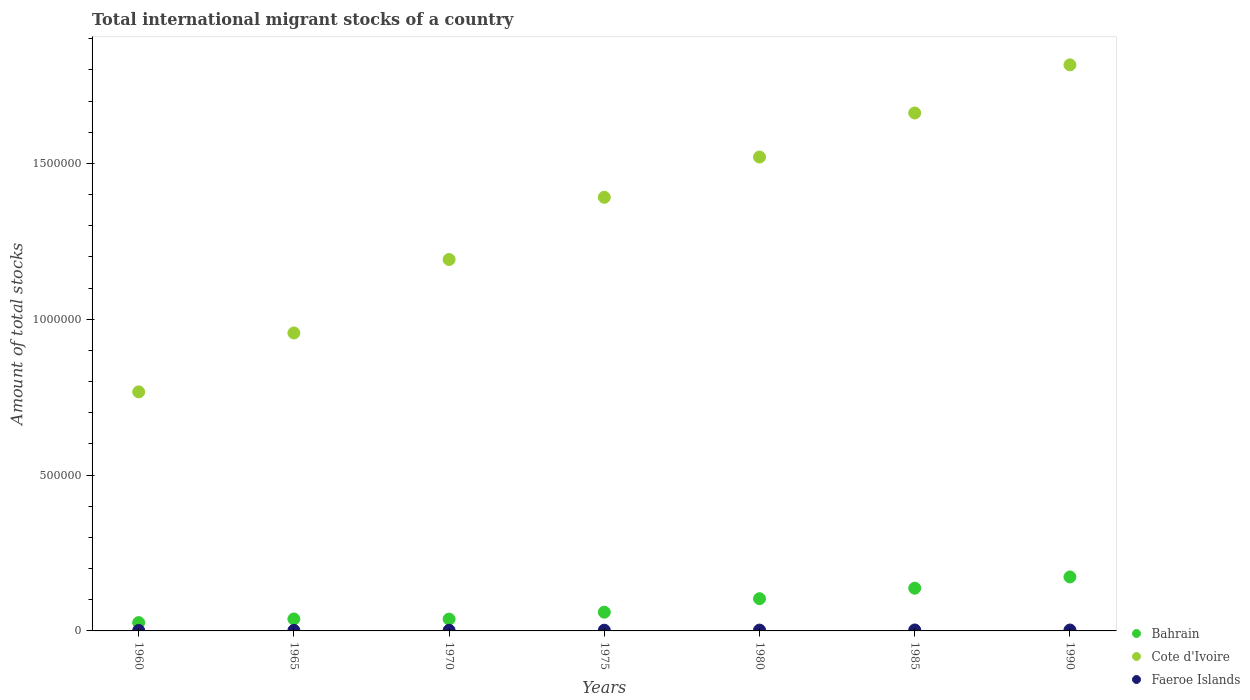Is the number of dotlines equal to the number of legend labels?
Your answer should be very brief. Yes. What is the amount of total stocks in in Bahrain in 1990?
Make the answer very short. 1.73e+05. Across all years, what is the maximum amount of total stocks in in Bahrain?
Provide a short and direct response. 1.73e+05. Across all years, what is the minimum amount of total stocks in in Bahrain?
Provide a short and direct response. 2.67e+04. In which year was the amount of total stocks in in Bahrain maximum?
Provide a short and direct response. 1990. What is the total amount of total stocks in in Faeroe Islands in the graph?
Offer a very short reply. 1.60e+04. What is the difference between the amount of total stocks in in Cote d'Ivoire in 1970 and that in 1980?
Your answer should be compact. -3.29e+05. What is the difference between the amount of total stocks in in Faeroe Islands in 1990 and the amount of total stocks in in Cote d'Ivoire in 1980?
Your answer should be compact. -1.52e+06. What is the average amount of total stocks in in Cote d'Ivoire per year?
Your response must be concise. 1.33e+06. In the year 1990, what is the difference between the amount of total stocks in in Cote d'Ivoire and amount of total stocks in in Bahrain?
Your answer should be compact. 1.64e+06. What is the ratio of the amount of total stocks in in Bahrain in 1960 to that in 1970?
Make the answer very short. 0.7. What is the difference between the highest and the second highest amount of total stocks in in Cote d'Ivoire?
Offer a terse response. 1.54e+05. What is the difference between the highest and the lowest amount of total stocks in in Cote d'Ivoire?
Provide a succinct answer. 1.05e+06. Is the amount of total stocks in in Cote d'Ivoire strictly greater than the amount of total stocks in in Faeroe Islands over the years?
Provide a succinct answer. Yes. Is the amount of total stocks in in Faeroe Islands strictly less than the amount of total stocks in in Bahrain over the years?
Provide a succinct answer. Yes. How many dotlines are there?
Ensure brevity in your answer.  3. Does the graph contain grids?
Provide a short and direct response. No. Where does the legend appear in the graph?
Ensure brevity in your answer.  Bottom right. How many legend labels are there?
Make the answer very short. 3. How are the legend labels stacked?
Your answer should be very brief. Vertical. What is the title of the graph?
Your answer should be very brief. Total international migrant stocks of a country. Does "Low income" appear as one of the legend labels in the graph?
Offer a terse response. No. What is the label or title of the Y-axis?
Your answer should be compact. Amount of total stocks. What is the Amount of total stocks of Bahrain in 1960?
Your response must be concise. 2.67e+04. What is the Amount of total stocks of Cote d'Ivoire in 1960?
Offer a very short reply. 7.67e+05. What is the Amount of total stocks in Faeroe Islands in 1960?
Offer a very short reply. 1489. What is the Amount of total stocks of Bahrain in 1965?
Provide a short and direct response. 3.84e+04. What is the Amount of total stocks of Cote d'Ivoire in 1965?
Offer a terse response. 9.56e+05. What is the Amount of total stocks of Faeroe Islands in 1965?
Offer a terse response. 1716. What is the Amount of total stocks of Bahrain in 1970?
Offer a very short reply. 3.79e+04. What is the Amount of total stocks in Cote d'Ivoire in 1970?
Your answer should be compact. 1.19e+06. What is the Amount of total stocks in Faeroe Islands in 1970?
Your response must be concise. 1978. What is the Amount of total stocks in Bahrain in 1975?
Offer a terse response. 6.01e+04. What is the Amount of total stocks in Cote d'Ivoire in 1975?
Your answer should be very brief. 1.39e+06. What is the Amount of total stocks of Faeroe Islands in 1975?
Offer a terse response. 2280. What is the Amount of total stocks in Bahrain in 1980?
Ensure brevity in your answer.  1.03e+05. What is the Amount of total stocks in Cote d'Ivoire in 1980?
Your answer should be very brief. 1.52e+06. What is the Amount of total stocks in Faeroe Islands in 1980?
Ensure brevity in your answer.  2628. What is the Amount of total stocks of Bahrain in 1985?
Keep it short and to the point. 1.37e+05. What is the Amount of total stocks of Cote d'Ivoire in 1985?
Your response must be concise. 1.66e+06. What is the Amount of total stocks in Faeroe Islands in 1985?
Offer a very short reply. 3029. What is the Amount of total stocks of Bahrain in 1990?
Offer a very short reply. 1.73e+05. What is the Amount of total stocks of Cote d'Ivoire in 1990?
Your answer should be compact. 1.82e+06. What is the Amount of total stocks of Faeroe Islands in 1990?
Offer a terse response. 2881. Across all years, what is the maximum Amount of total stocks in Bahrain?
Provide a succinct answer. 1.73e+05. Across all years, what is the maximum Amount of total stocks of Cote d'Ivoire?
Provide a succinct answer. 1.82e+06. Across all years, what is the maximum Amount of total stocks of Faeroe Islands?
Offer a very short reply. 3029. Across all years, what is the minimum Amount of total stocks in Bahrain?
Your answer should be compact. 2.67e+04. Across all years, what is the minimum Amount of total stocks in Cote d'Ivoire?
Provide a succinct answer. 7.67e+05. Across all years, what is the minimum Amount of total stocks of Faeroe Islands?
Your answer should be very brief. 1489. What is the total Amount of total stocks in Bahrain in the graph?
Provide a short and direct response. 5.77e+05. What is the total Amount of total stocks of Cote d'Ivoire in the graph?
Keep it short and to the point. 9.31e+06. What is the total Amount of total stocks in Faeroe Islands in the graph?
Ensure brevity in your answer.  1.60e+04. What is the difference between the Amount of total stocks in Bahrain in 1960 and that in 1965?
Make the answer very short. -1.16e+04. What is the difference between the Amount of total stocks of Cote d'Ivoire in 1960 and that in 1965?
Your answer should be compact. -1.89e+05. What is the difference between the Amount of total stocks of Faeroe Islands in 1960 and that in 1965?
Ensure brevity in your answer.  -227. What is the difference between the Amount of total stocks in Bahrain in 1960 and that in 1970?
Provide a succinct answer. -1.12e+04. What is the difference between the Amount of total stocks in Cote d'Ivoire in 1960 and that in 1970?
Your response must be concise. -4.25e+05. What is the difference between the Amount of total stocks of Faeroe Islands in 1960 and that in 1970?
Give a very brief answer. -489. What is the difference between the Amount of total stocks in Bahrain in 1960 and that in 1975?
Give a very brief answer. -3.34e+04. What is the difference between the Amount of total stocks of Cote d'Ivoire in 1960 and that in 1975?
Offer a terse response. -6.24e+05. What is the difference between the Amount of total stocks of Faeroe Islands in 1960 and that in 1975?
Your answer should be compact. -791. What is the difference between the Amount of total stocks of Bahrain in 1960 and that in 1980?
Provide a short and direct response. -7.67e+04. What is the difference between the Amount of total stocks in Cote d'Ivoire in 1960 and that in 1980?
Offer a very short reply. -7.54e+05. What is the difference between the Amount of total stocks of Faeroe Islands in 1960 and that in 1980?
Ensure brevity in your answer.  -1139. What is the difference between the Amount of total stocks in Bahrain in 1960 and that in 1985?
Offer a very short reply. -1.10e+05. What is the difference between the Amount of total stocks in Cote d'Ivoire in 1960 and that in 1985?
Keep it short and to the point. -8.95e+05. What is the difference between the Amount of total stocks in Faeroe Islands in 1960 and that in 1985?
Provide a short and direct response. -1540. What is the difference between the Amount of total stocks in Bahrain in 1960 and that in 1990?
Provide a short and direct response. -1.46e+05. What is the difference between the Amount of total stocks in Cote d'Ivoire in 1960 and that in 1990?
Provide a short and direct response. -1.05e+06. What is the difference between the Amount of total stocks in Faeroe Islands in 1960 and that in 1990?
Give a very brief answer. -1392. What is the difference between the Amount of total stocks of Bahrain in 1965 and that in 1970?
Provide a succinct answer. 411. What is the difference between the Amount of total stocks in Cote d'Ivoire in 1965 and that in 1970?
Your response must be concise. -2.36e+05. What is the difference between the Amount of total stocks of Faeroe Islands in 1965 and that in 1970?
Your answer should be compact. -262. What is the difference between the Amount of total stocks of Bahrain in 1965 and that in 1975?
Offer a very short reply. -2.17e+04. What is the difference between the Amount of total stocks of Cote d'Ivoire in 1965 and that in 1975?
Your answer should be very brief. -4.35e+05. What is the difference between the Amount of total stocks of Faeroe Islands in 1965 and that in 1975?
Ensure brevity in your answer.  -564. What is the difference between the Amount of total stocks in Bahrain in 1965 and that in 1980?
Provide a short and direct response. -6.51e+04. What is the difference between the Amount of total stocks of Cote d'Ivoire in 1965 and that in 1980?
Give a very brief answer. -5.65e+05. What is the difference between the Amount of total stocks of Faeroe Islands in 1965 and that in 1980?
Provide a succinct answer. -912. What is the difference between the Amount of total stocks of Bahrain in 1965 and that in 1985?
Your answer should be very brief. -9.87e+04. What is the difference between the Amount of total stocks of Cote d'Ivoire in 1965 and that in 1985?
Provide a succinct answer. -7.06e+05. What is the difference between the Amount of total stocks of Faeroe Islands in 1965 and that in 1985?
Offer a very short reply. -1313. What is the difference between the Amount of total stocks of Bahrain in 1965 and that in 1990?
Your answer should be very brief. -1.35e+05. What is the difference between the Amount of total stocks of Cote d'Ivoire in 1965 and that in 1990?
Your answer should be compact. -8.60e+05. What is the difference between the Amount of total stocks of Faeroe Islands in 1965 and that in 1990?
Your response must be concise. -1165. What is the difference between the Amount of total stocks of Bahrain in 1970 and that in 1975?
Offer a very short reply. -2.21e+04. What is the difference between the Amount of total stocks of Cote d'Ivoire in 1970 and that in 1975?
Offer a very short reply. -2.00e+05. What is the difference between the Amount of total stocks in Faeroe Islands in 1970 and that in 1975?
Provide a succinct answer. -302. What is the difference between the Amount of total stocks of Bahrain in 1970 and that in 1980?
Give a very brief answer. -6.55e+04. What is the difference between the Amount of total stocks in Cote d'Ivoire in 1970 and that in 1980?
Make the answer very short. -3.29e+05. What is the difference between the Amount of total stocks of Faeroe Islands in 1970 and that in 1980?
Make the answer very short. -650. What is the difference between the Amount of total stocks in Bahrain in 1970 and that in 1985?
Keep it short and to the point. -9.91e+04. What is the difference between the Amount of total stocks of Cote d'Ivoire in 1970 and that in 1985?
Give a very brief answer. -4.70e+05. What is the difference between the Amount of total stocks in Faeroe Islands in 1970 and that in 1985?
Your answer should be compact. -1051. What is the difference between the Amount of total stocks of Bahrain in 1970 and that in 1990?
Make the answer very short. -1.35e+05. What is the difference between the Amount of total stocks in Cote d'Ivoire in 1970 and that in 1990?
Ensure brevity in your answer.  -6.25e+05. What is the difference between the Amount of total stocks in Faeroe Islands in 1970 and that in 1990?
Ensure brevity in your answer.  -903. What is the difference between the Amount of total stocks of Bahrain in 1975 and that in 1980?
Your response must be concise. -4.34e+04. What is the difference between the Amount of total stocks of Cote d'Ivoire in 1975 and that in 1980?
Your answer should be compact. -1.29e+05. What is the difference between the Amount of total stocks of Faeroe Islands in 1975 and that in 1980?
Offer a very short reply. -348. What is the difference between the Amount of total stocks of Bahrain in 1975 and that in 1985?
Your response must be concise. -7.70e+04. What is the difference between the Amount of total stocks in Cote d'Ivoire in 1975 and that in 1985?
Provide a succinct answer. -2.71e+05. What is the difference between the Amount of total stocks of Faeroe Islands in 1975 and that in 1985?
Your response must be concise. -749. What is the difference between the Amount of total stocks of Bahrain in 1975 and that in 1990?
Your response must be concise. -1.13e+05. What is the difference between the Amount of total stocks in Cote d'Ivoire in 1975 and that in 1990?
Keep it short and to the point. -4.25e+05. What is the difference between the Amount of total stocks in Faeroe Islands in 1975 and that in 1990?
Your response must be concise. -601. What is the difference between the Amount of total stocks of Bahrain in 1980 and that in 1985?
Your answer should be compact. -3.36e+04. What is the difference between the Amount of total stocks in Cote d'Ivoire in 1980 and that in 1985?
Offer a terse response. -1.41e+05. What is the difference between the Amount of total stocks of Faeroe Islands in 1980 and that in 1985?
Provide a succinct answer. -401. What is the difference between the Amount of total stocks in Bahrain in 1980 and that in 1990?
Provide a short and direct response. -6.97e+04. What is the difference between the Amount of total stocks in Cote d'Ivoire in 1980 and that in 1990?
Provide a succinct answer. -2.96e+05. What is the difference between the Amount of total stocks in Faeroe Islands in 1980 and that in 1990?
Provide a short and direct response. -253. What is the difference between the Amount of total stocks in Bahrain in 1985 and that in 1990?
Provide a succinct answer. -3.61e+04. What is the difference between the Amount of total stocks in Cote d'Ivoire in 1985 and that in 1990?
Provide a short and direct response. -1.54e+05. What is the difference between the Amount of total stocks of Faeroe Islands in 1985 and that in 1990?
Provide a succinct answer. 148. What is the difference between the Amount of total stocks in Bahrain in 1960 and the Amount of total stocks in Cote d'Ivoire in 1965?
Offer a very short reply. -9.29e+05. What is the difference between the Amount of total stocks of Bahrain in 1960 and the Amount of total stocks of Faeroe Islands in 1965?
Offer a terse response. 2.50e+04. What is the difference between the Amount of total stocks of Cote d'Ivoire in 1960 and the Amount of total stocks of Faeroe Islands in 1965?
Give a very brief answer. 7.65e+05. What is the difference between the Amount of total stocks of Bahrain in 1960 and the Amount of total stocks of Cote d'Ivoire in 1970?
Ensure brevity in your answer.  -1.17e+06. What is the difference between the Amount of total stocks in Bahrain in 1960 and the Amount of total stocks in Faeroe Islands in 1970?
Your answer should be compact. 2.48e+04. What is the difference between the Amount of total stocks of Cote d'Ivoire in 1960 and the Amount of total stocks of Faeroe Islands in 1970?
Offer a very short reply. 7.65e+05. What is the difference between the Amount of total stocks in Bahrain in 1960 and the Amount of total stocks in Cote d'Ivoire in 1975?
Keep it short and to the point. -1.36e+06. What is the difference between the Amount of total stocks of Bahrain in 1960 and the Amount of total stocks of Faeroe Islands in 1975?
Provide a short and direct response. 2.45e+04. What is the difference between the Amount of total stocks of Cote d'Ivoire in 1960 and the Amount of total stocks of Faeroe Islands in 1975?
Keep it short and to the point. 7.65e+05. What is the difference between the Amount of total stocks of Bahrain in 1960 and the Amount of total stocks of Cote d'Ivoire in 1980?
Ensure brevity in your answer.  -1.49e+06. What is the difference between the Amount of total stocks of Bahrain in 1960 and the Amount of total stocks of Faeroe Islands in 1980?
Ensure brevity in your answer.  2.41e+04. What is the difference between the Amount of total stocks of Cote d'Ivoire in 1960 and the Amount of total stocks of Faeroe Islands in 1980?
Give a very brief answer. 7.64e+05. What is the difference between the Amount of total stocks in Bahrain in 1960 and the Amount of total stocks in Cote d'Ivoire in 1985?
Give a very brief answer. -1.64e+06. What is the difference between the Amount of total stocks in Bahrain in 1960 and the Amount of total stocks in Faeroe Islands in 1985?
Provide a short and direct response. 2.37e+04. What is the difference between the Amount of total stocks in Cote d'Ivoire in 1960 and the Amount of total stocks in Faeroe Islands in 1985?
Give a very brief answer. 7.64e+05. What is the difference between the Amount of total stocks in Bahrain in 1960 and the Amount of total stocks in Cote d'Ivoire in 1990?
Provide a succinct answer. -1.79e+06. What is the difference between the Amount of total stocks in Bahrain in 1960 and the Amount of total stocks in Faeroe Islands in 1990?
Your response must be concise. 2.39e+04. What is the difference between the Amount of total stocks of Cote d'Ivoire in 1960 and the Amount of total stocks of Faeroe Islands in 1990?
Your response must be concise. 7.64e+05. What is the difference between the Amount of total stocks in Bahrain in 1965 and the Amount of total stocks in Cote d'Ivoire in 1970?
Make the answer very short. -1.15e+06. What is the difference between the Amount of total stocks in Bahrain in 1965 and the Amount of total stocks in Faeroe Islands in 1970?
Your answer should be very brief. 3.64e+04. What is the difference between the Amount of total stocks in Cote d'Ivoire in 1965 and the Amount of total stocks in Faeroe Islands in 1970?
Your response must be concise. 9.54e+05. What is the difference between the Amount of total stocks in Bahrain in 1965 and the Amount of total stocks in Cote d'Ivoire in 1975?
Offer a very short reply. -1.35e+06. What is the difference between the Amount of total stocks of Bahrain in 1965 and the Amount of total stocks of Faeroe Islands in 1975?
Provide a succinct answer. 3.61e+04. What is the difference between the Amount of total stocks in Cote d'Ivoire in 1965 and the Amount of total stocks in Faeroe Islands in 1975?
Your response must be concise. 9.54e+05. What is the difference between the Amount of total stocks of Bahrain in 1965 and the Amount of total stocks of Cote d'Ivoire in 1980?
Offer a terse response. -1.48e+06. What is the difference between the Amount of total stocks in Bahrain in 1965 and the Amount of total stocks in Faeroe Islands in 1980?
Your response must be concise. 3.57e+04. What is the difference between the Amount of total stocks of Cote d'Ivoire in 1965 and the Amount of total stocks of Faeroe Islands in 1980?
Offer a terse response. 9.53e+05. What is the difference between the Amount of total stocks of Bahrain in 1965 and the Amount of total stocks of Cote d'Ivoire in 1985?
Make the answer very short. -1.62e+06. What is the difference between the Amount of total stocks in Bahrain in 1965 and the Amount of total stocks in Faeroe Islands in 1985?
Provide a short and direct response. 3.53e+04. What is the difference between the Amount of total stocks in Cote d'Ivoire in 1965 and the Amount of total stocks in Faeroe Islands in 1985?
Provide a short and direct response. 9.53e+05. What is the difference between the Amount of total stocks of Bahrain in 1965 and the Amount of total stocks of Cote d'Ivoire in 1990?
Give a very brief answer. -1.78e+06. What is the difference between the Amount of total stocks of Bahrain in 1965 and the Amount of total stocks of Faeroe Islands in 1990?
Your answer should be very brief. 3.55e+04. What is the difference between the Amount of total stocks of Cote d'Ivoire in 1965 and the Amount of total stocks of Faeroe Islands in 1990?
Make the answer very short. 9.53e+05. What is the difference between the Amount of total stocks of Bahrain in 1970 and the Amount of total stocks of Cote d'Ivoire in 1975?
Make the answer very short. -1.35e+06. What is the difference between the Amount of total stocks in Bahrain in 1970 and the Amount of total stocks in Faeroe Islands in 1975?
Your answer should be compact. 3.57e+04. What is the difference between the Amount of total stocks in Cote d'Ivoire in 1970 and the Amount of total stocks in Faeroe Islands in 1975?
Provide a short and direct response. 1.19e+06. What is the difference between the Amount of total stocks of Bahrain in 1970 and the Amount of total stocks of Cote d'Ivoire in 1980?
Your response must be concise. -1.48e+06. What is the difference between the Amount of total stocks in Bahrain in 1970 and the Amount of total stocks in Faeroe Islands in 1980?
Give a very brief answer. 3.53e+04. What is the difference between the Amount of total stocks of Cote d'Ivoire in 1970 and the Amount of total stocks of Faeroe Islands in 1980?
Your answer should be very brief. 1.19e+06. What is the difference between the Amount of total stocks of Bahrain in 1970 and the Amount of total stocks of Cote d'Ivoire in 1985?
Your response must be concise. -1.62e+06. What is the difference between the Amount of total stocks of Bahrain in 1970 and the Amount of total stocks of Faeroe Islands in 1985?
Give a very brief answer. 3.49e+04. What is the difference between the Amount of total stocks of Cote d'Ivoire in 1970 and the Amount of total stocks of Faeroe Islands in 1985?
Provide a short and direct response. 1.19e+06. What is the difference between the Amount of total stocks in Bahrain in 1970 and the Amount of total stocks in Cote d'Ivoire in 1990?
Ensure brevity in your answer.  -1.78e+06. What is the difference between the Amount of total stocks in Bahrain in 1970 and the Amount of total stocks in Faeroe Islands in 1990?
Ensure brevity in your answer.  3.51e+04. What is the difference between the Amount of total stocks of Cote d'Ivoire in 1970 and the Amount of total stocks of Faeroe Islands in 1990?
Your answer should be compact. 1.19e+06. What is the difference between the Amount of total stocks of Bahrain in 1975 and the Amount of total stocks of Cote d'Ivoire in 1980?
Give a very brief answer. -1.46e+06. What is the difference between the Amount of total stocks of Bahrain in 1975 and the Amount of total stocks of Faeroe Islands in 1980?
Make the answer very short. 5.75e+04. What is the difference between the Amount of total stocks of Cote d'Ivoire in 1975 and the Amount of total stocks of Faeroe Islands in 1980?
Offer a terse response. 1.39e+06. What is the difference between the Amount of total stocks of Bahrain in 1975 and the Amount of total stocks of Cote d'Ivoire in 1985?
Ensure brevity in your answer.  -1.60e+06. What is the difference between the Amount of total stocks of Bahrain in 1975 and the Amount of total stocks of Faeroe Islands in 1985?
Your response must be concise. 5.71e+04. What is the difference between the Amount of total stocks in Cote d'Ivoire in 1975 and the Amount of total stocks in Faeroe Islands in 1985?
Your response must be concise. 1.39e+06. What is the difference between the Amount of total stocks in Bahrain in 1975 and the Amount of total stocks in Cote d'Ivoire in 1990?
Your answer should be compact. -1.76e+06. What is the difference between the Amount of total stocks in Bahrain in 1975 and the Amount of total stocks in Faeroe Islands in 1990?
Keep it short and to the point. 5.72e+04. What is the difference between the Amount of total stocks of Cote d'Ivoire in 1975 and the Amount of total stocks of Faeroe Islands in 1990?
Ensure brevity in your answer.  1.39e+06. What is the difference between the Amount of total stocks of Bahrain in 1980 and the Amount of total stocks of Cote d'Ivoire in 1985?
Provide a succinct answer. -1.56e+06. What is the difference between the Amount of total stocks in Bahrain in 1980 and the Amount of total stocks in Faeroe Islands in 1985?
Give a very brief answer. 1.00e+05. What is the difference between the Amount of total stocks in Cote d'Ivoire in 1980 and the Amount of total stocks in Faeroe Islands in 1985?
Give a very brief answer. 1.52e+06. What is the difference between the Amount of total stocks in Bahrain in 1980 and the Amount of total stocks in Cote d'Ivoire in 1990?
Your answer should be very brief. -1.71e+06. What is the difference between the Amount of total stocks of Bahrain in 1980 and the Amount of total stocks of Faeroe Islands in 1990?
Keep it short and to the point. 1.01e+05. What is the difference between the Amount of total stocks of Cote d'Ivoire in 1980 and the Amount of total stocks of Faeroe Islands in 1990?
Keep it short and to the point. 1.52e+06. What is the difference between the Amount of total stocks in Bahrain in 1985 and the Amount of total stocks in Cote d'Ivoire in 1990?
Your response must be concise. -1.68e+06. What is the difference between the Amount of total stocks of Bahrain in 1985 and the Amount of total stocks of Faeroe Islands in 1990?
Your answer should be very brief. 1.34e+05. What is the difference between the Amount of total stocks in Cote d'Ivoire in 1985 and the Amount of total stocks in Faeroe Islands in 1990?
Make the answer very short. 1.66e+06. What is the average Amount of total stocks in Bahrain per year?
Your answer should be very brief. 8.24e+04. What is the average Amount of total stocks in Cote d'Ivoire per year?
Make the answer very short. 1.33e+06. What is the average Amount of total stocks of Faeroe Islands per year?
Ensure brevity in your answer.  2285.86. In the year 1960, what is the difference between the Amount of total stocks of Bahrain and Amount of total stocks of Cote d'Ivoire?
Your response must be concise. -7.40e+05. In the year 1960, what is the difference between the Amount of total stocks of Bahrain and Amount of total stocks of Faeroe Islands?
Offer a very short reply. 2.52e+04. In the year 1960, what is the difference between the Amount of total stocks of Cote d'Ivoire and Amount of total stocks of Faeroe Islands?
Give a very brief answer. 7.66e+05. In the year 1965, what is the difference between the Amount of total stocks in Bahrain and Amount of total stocks in Cote d'Ivoire?
Your response must be concise. -9.18e+05. In the year 1965, what is the difference between the Amount of total stocks of Bahrain and Amount of total stocks of Faeroe Islands?
Keep it short and to the point. 3.66e+04. In the year 1965, what is the difference between the Amount of total stocks in Cote d'Ivoire and Amount of total stocks in Faeroe Islands?
Provide a short and direct response. 9.54e+05. In the year 1970, what is the difference between the Amount of total stocks in Bahrain and Amount of total stocks in Cote d'Ivoire?
Your response must be concise. -1.15e+06. In the year 1970, what is the difference between the Amount of total stocks of Bahrain and Amount of total stocks of Faeroe Islands?
Your answer should be compact. 3.60e+04. In the year 1970, what is the difference between the Amount of total stocks in Cote d'Ivoire and Amount of total stocks in Faeroe Islands?
Ensure brevity in your answer.  1.19e+06. In the year 1975, what is the difference between the Amount of total stocks in Bahrain and Amount of total stocks in Cote d'Ivoire?
Ensure brevity in your answer.  -1.33e+06. In the year 1975, what is the difference between the Amount of total stocks in Bahrain and Amount of total stocks in Faeroe Islands?
Keep it short and to the point. 5.78e+04. In the year 1975, what is the difference between the Amount of total stocks in Cote d'Ivoire and Amount of total stocks in Faeroe Islands?
Keep it short and to the point. 1.39e+06. In the year 1980, what is the difference between the Amount of total stocks in Bahrain and Amount of total stocks in Cote d'Ivoire?
Make the answer very short. -1.42e+06. In the year 1980, what is the difference between the Amount of total stocks of Bahrain and Amount of total stocks of Faeroe Islands?
Give a very brief answer. 1.01e+05. In the year 1980, what is the difference between the Amount of total stocks in Cote d'Ivoire and Amount of total stocks in Faeroe Islands?
Your answer should be very brief. 1.52e+06. In the year 1985, what is the difference between the Amount of total stocks of Bahrain and Amount of total stocks of Cote d'Ivoire?
Offer a very short reply. -1.52e+06. In the year 1985, what is the difference between the Amount of total stocks in Bahrain and Amount of total stocks in Faeroe Islands?
Offer a very short reply. 1.34e+05. In the year 1985, what is the difference between the Amount of total stocks in Cote d'Ivoire and Amount of total stocks in Faeroe Islands?
Give a very brief answer. 1.66e+06. In the year 1990, what is the difference between the Amount of total stocks in Bahrain and Amount of total stocks in Cote d'Ivoire?
Keep it short and to the point. -1.64e+06. In the year 1990, what is the difference between the Amount of total stocks in Bahrain and Amount of total stocks in Faeroe Islands?
Your response must be concise. 1.70e+05. In the year 1990, what is the difference between the Amount of total stocks in Cote d'Ivoire and Amount of total stocks in Faeroe Islands?
Make the answer very short. 1.81e+06. What is the ratio of the Amount of total stocks in Bahrain in 1960 to that in 1965?
Offer a terse response. 0.7. What is the ratio of the Amount of total stocks of Cote d'Ivoire in 1960 to that in 1965?
Provide a short and direct response. 0.8. What is the ratio of the Amount of total stocks in Faeroe Islands in 1960 to that in 1965?
Offer a terse response. 0.87. What is the ratio of the Amount of total stocks in Bahrain in 1960 to that in 1970?
Offer a very short reply. 0.7. What is the ratio of the Amount of total stocks of Cote d'Ivoire in 1960 to that in 1970?
Ensure brevity in your answer.  0.64. What is the ratio of the Amount of total stocks of Faeroe Islands in 1960 to that in 1970?
Provide a short and direct response. 0.75. What is the ratio of the Amount of total stocks in Bahrain in 1960 to that in 1975?
Offer a very short reply. 0.44. What is the ratio of the Amount of total stocks in Cote d'Ivoire in 1960 to that in 1975?
Provide a succinct answer. 0.55. What is the ratio of the Amount of total stocks in Faeroe Islands in 1960 to that in 1975?
Make the answer very short. 0.65. What is the ratio of the Amount of total stocks in Bahrain in 1960 to that in 1980?
Provide a succinct answer. 0.26. What is the ratio of the Amount of total stocks of Cote d'Ivoire in 1960 to that in 1980?
Ensure brevity in your answer.  0.5. What is the ratio of the Amount of total stocks in Faeroe Islands in 1960 to that in 1980?
Make the answer very short. 0.57. What is the ratio of the Amount of total stocks in Bahrain in 1960 to that in 1985?
Ensure brevity in your answer.  0.2. What is the ratio of the Amount of total stocks in Cote d'Ivoire in 1960 to that in 1985?
Make the answer very short. 0.46. What is the ratio of the Amount of total stocks in Faeroe Islands in 1960 to that in 1985?
Offer a terse response. 0.49. What is the ratio of the Amount of total stocks of Bahrain in 1960 to that in 1990?
Your answer should be compact. 0.15. What is the ratio of the Amount of total stocks of Cote d'Ivoire in 1960 to that in 1990?
Offer a very short reply. 0.42. What is the ratio of the Amount of total stocks of Faeroe Islands in 1960 to that in 1990?
Your answer should be compact. 0.52. What is the ratio of the Amount of total stocks of Bahrain in 1965 to that in 1970?
Offer a terse response. 1.01. What is the ratio of the Amount of total stocks in Cote d'Ivoire in 1965 to that in 1970?
Your answer should be very brief. 0.8. What is the ratio of the Amount of total stocks in Faeroe Islands in 1965 to that in 1970?
Give a very brief answer. 0.87. What is the ratio of the Amount of total stocks in Bahrain in 1965 to that in 1975?
Give a very brief answer. 0.64. What is the ratio of the Amount of total stocks of Cote d'Ivoire in 1965 to that in 1975?
Make the answer very short. 0.69. What is the ratio of the Amount of total stocks of Faeroe Islands in 1965 to that in 1975?
Make the answer very short. 0.75. What is the ratio of the Amount of total stocks of Bahrain in 1965 to that in 1980?
Provide a succinct answer. 0.37. What is the ratio of the Amount of total stocks of Cote d'Ivoire in 1965 to that in 1980?
Your answer should be very brief. 0.63. What is the ratio of the Amount of total stocks of Faeroe Islands in 1965 to that in 1980?
Give a very brief answer. 0.65. What is the ratio of the Amount of total stocks of Bahrain in 1965 to that in 1985?
Provide a short and direct response. 0.28. What is the ratio of the Amount of total stocks in Cote d'Ivoire in 1965 to that in 1985?
Your answer should be very brief. 0.58. What is the ratio of the Amount of total stocks of Faeroe Islands in 1965 to that in 1985?
Make the answer very short. 0.57. What is the ratio of the Amount of total stocks in Bahrain in 1965 to that in 1990?
Offer a terse response. 0.22. What is the ratio of the Amount of total stocks in Cote d'Ivoire in 1965 to that in 1990?
Make the answer very short. 0.53. What is the ratio of the Amount of total stocks of Faeroe Islands in 1965 to that in 1990?
Give a very brief answer. 0.6. What is the ratio of the Amount of total stocks of Bahrain in 1970 to that in 1975?
Ensure brevity in your answer.  0.63. What is the ratio of the Amount of total stocks in Cote d'Ivoire in 1970 to that in 1975?
Provide a short and direct response. 0.86. What is the ratio of the Amount of total stocks in Faeroe Islands in 1970 to that in 1975?
Offer a very short reply. 0.87. What is the ratio of the Amount of total stocks in Bahrain in 1970 to that in 1980?
Make the answer very short. 0.37. What is the ratio of the Amount of total stocks in Cote d'Ivoire in 1970 to that in 1980?
Provide a short and direct response. 0.78. What is the ratio of the Amount of total stocks in Faeroe Islands in 1970 to that in 1980?
Give a very brief answer. 0.75. What is the ratio of the Amount of total stocks in Bahrain in 1970 to that in 1985?
Give a very brief answer. 0.28. What is the ratio of the Amount of total stocks in Cote d'Ivoire in 1970 to that in 1985?
Your answer should be very brief. 0.72. What is the ratio of the Amount of total stocks in Faeroe Islands in 1970 to that in 1985?
Your response must be concise. 0.65. What is the ratio of the Amount of total stocks in Bahrain in 1970 to that in 1990?
Your answer should be very brief. 0.22. What is the ratio of the Amount of total stocks in Cote d'Ivoire in 1970 to that in 1990?
Offer a very short reply. 0.66. What is the ratio of the Amount of total stocks of Faeroe Islands in 1970 to that in 1990?
Your answer should be very brief. 0.69. What is the ratio of the Amount of total stocks in Bahrain in 1975 to that in 1980?
Your answer should be very brief. 0.58. What is the ratio of the Amount of total stocks of Cote d'Ivoire in 1975 to that in 1980?
Make the answer very short. 0.92. What is the ratio of the Amount of total stocks in Faeroe Islands in 1975 to that in 1980?
Offer a terse response. 0.87. What is the ratio of the Amount of total stocks of Bahrain in 1975 to that in 1985?
Offer a terse response. 0.44. What is the ratio of the Amount of total stocks in Cote d'Ivoire in 1975 to that in 1985?
Give a very brief answer. 0.84. What is the ratio of the Amount of total stocks of Faeroe Islands in 1975 to that in 1985?
Provide a short and direct response. 0.75. What is the ratio of the Amount of total stocks of Bahrain in 1975 to that in 1990?
Keep it short and to the point. 0.35. What is the ratio of the Amount of total stocks in Cote d'Ivoire in 1975 to that in 1990?
Keep it short and to the point. 0.77. What is the ratio of the Amount of total stocks in Faeroe Islands in 1975 to that in 1990?
Offer a terse response. 0.79. What is the ratio of the Amount of total stocks of Bahrain in 1980 to that in 1985?
Your answer should be very brief. 0.75. What is the ratio of the Amount of total stocks of Cote d'Ivoire in 1980 to that in 1985?
Offer a very short reply. 0.92. What is the ratio of the Amount of total stocks of Faeroe Islands in 1980 to that in 1985?
Make the answer very short. 0.87. What is the ratio of the Amount of total stocks of Bahrain in 1980 to that in 1990?
Your response must be concise. 0.6. What is the ratio of the Amount of total stocks of Cote d'Ivoire in 1980 to that in 1990?
Make the answer very short. 0.84. What is the ratio of the Amount of total stocks in Faeroe Islands in 1980 to that in 1990?
Offer a terse response. 0.91. What is the ratio of the Amount of total stocks of Bahrain in 1985 to that in 1990?
Your answer should be compact. 0.79. What is the ratio of the Amount of total stocks in Cote d'Ivoire in 1985 to that in 1990?
Your response must be concise. 0.92. What is the ratio of the Amount of total stocks of Faeroe Islands in 1985 to that in 1990?
Give a very brief answer. 1.05. What is the difference between the highest and the second highest Amount of total stocks in Bahrain?
Make the answer very short. 3.61e+04. What is the difference between the highest and the second highest Amount of total stocks of Cote d'Ivoire?
Give a very brief answer. 1.54e+05. What is the difference between the highest and the second highest Amount of total stocks in Faeroe Islands?
Provide a short and direct response. 148. What is the difference between the highest and the lowest Amount of total stocks of Bahrain?
Provide a succinct answer. 1.46e+05. What is the difference between the highest and the lowest Amount of total stocks of Cote d'Ivoire?
Make the answer very short. 1.05e+06. What is the difference between the highest and the lowest Amount of total stocks of Faeroe Islands?
Your answer should be very brief. 1540. 